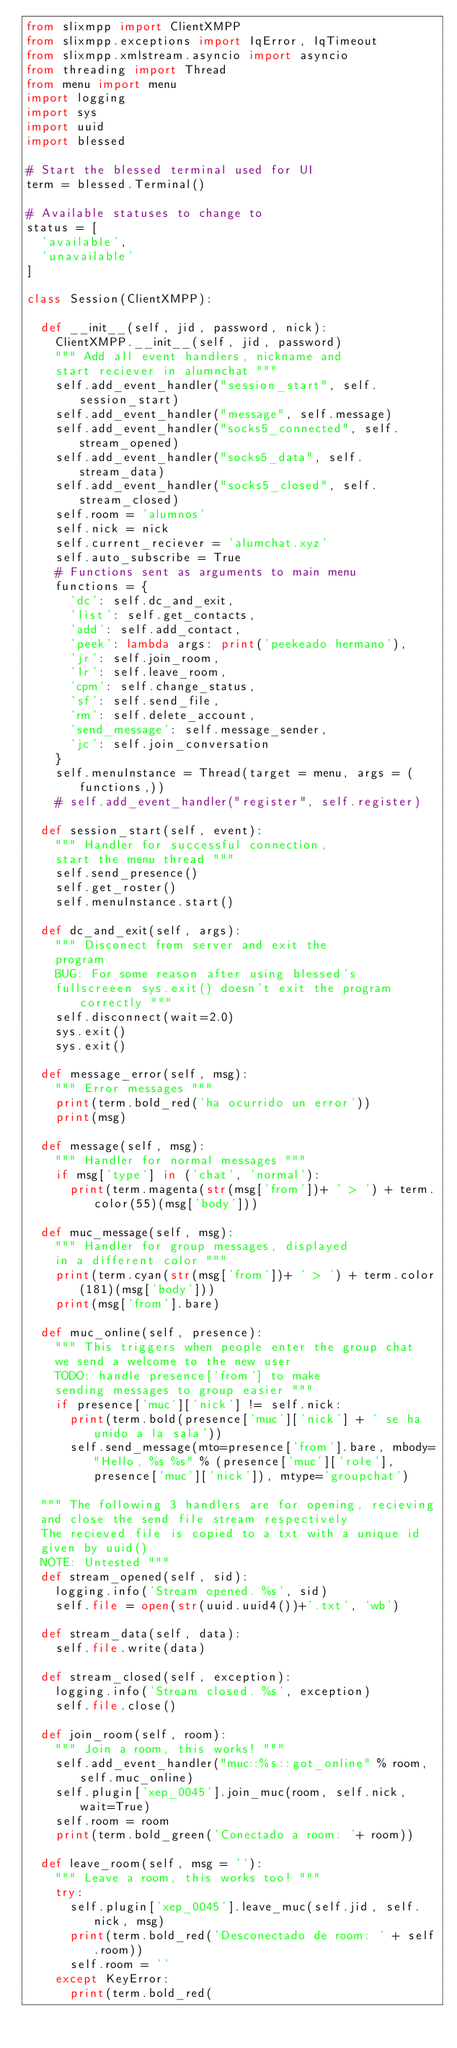<code> <loc_0><loc_0><loc_500><loc_500><_Python_>from slixmpp import ClientXMPP
from slixmpp.exceptions import IqError, IqTimeout
from slixmpp.xmlstream.asyncio import asyncio
from threading import Thread
from menu import menu
import logging
import sys
import uuid
import blessed

# Start the blessed terminal used for UI
term = blessed.Terminal()

# Available statuses to change to
status = [
  'available',
  'unavailable'
]

class Session(ClientXMPP):

  def __init__(self, jid, password, nick):
    ClientXMPP.__init__(self, jid, password)
    """ Add all event handlers, nickname and
    start reciever in alumnchat """
    self.add_event_handler("session_start", self.session_start)
    self.add_event_handler("message", self.message)
    self.add_event_handler("socks5_connected", self.stream_opened)
    self.add_event_handler("socks5_data", self.stream_data)
    self.add_event_handler("socks5_closed", self.stream_closed)
    self.room = 'alumnos'
    self.nick = nick
    self.current_reciever = 'alumchat.xyz'
    self.auto_subscribe = True
    # Functions sent as arguments to main menu
    functions = {
      'dc': self.dc_and_exit,
      'list': self.get_contacts,
      'add': self.add_contact,
      'peek': lambda args: print('peekeado hermano'),
      'jr': self.join_room,
      'lr': self.leave_room,
      'cpm': self.change_status,
      'sf': self.send_file,
      'rm': self.delete_account,
      'send_message': self.message_sender,
      'jc': self.join_conversation
    }
    self.menuInstance = Thread(target = menu, args = (functions,))
    # self.add_event_handler("register", self.register)

  def session_start(self, event):
    """ Handler for successful connection,
    start the menu thread """
    self.send_presence()
    self.get_roster()
    self.menuInstance.start()
    
  def dc_and_exit(self, args):
    """ Disconect from server and exit the 
    program
    BUG: For some reason after using blessed's
    fullscreeen sys.exit() doesn't exit the program correctly """
    self.disconnect(wait=2.0)
    sys.exit()
    sys.exit()

  def message_error(self, msg):
    """ Error messages """
    print(term.bold_red('ha ocurrido un error'))
    print(msg)
  
  def message(self, msg):
    """ Handler for normal messages """
    if msg['type'] in ('chat', 'normal'):
      print(term.magenta(str(msg['from'])+ ' > ') + term.color(55)(msg['body']))

  def muc_message(self, msg):
    """ Handler for group messages, displayed
    in a different color """
    print(term.cyan(str(msg['from'])+ ' > ') + term.color(181)(msg['body']))
    print(msg['from'].bare)
  
  def muc_online(self, presence):
    """ This triggers when people enter the group chat
    we send a welcome to the new user
    TODO: handle presence['from'] to make
    sending messages to group easier """
    if presence['muc']['nick'] != self.nick:
      print(term.bold(presence['muc']['nick'] + ' se ha unido a la sala'))
      self.send_message(mto=presence['from'].bare, mbody="Hello, %s %s" % (presence['muc']['role'], presence['muc']['nick']), mtype='groupchat')

  """ The following 3 handlers are for opening, recieving
  and close the send file stream respectively 
  The recieved file is copied to a txt with a unique id
  given by uuid()
  NOTE: Untested """
  def stream_opened(self, sid):
    logging.info('Stream opened. %s', sid)
    self.file = open(str(uuid.uuid4())+'.txt', 'wb')

  def stream_data(self, data):
    self.file.write(data)

  def stream_closed(self, exception):
    logging.info('Stream closed. %s', exception)
    self.file.close()
  
  def join_room(self, room):
    """ Join a room, this works! """
    self.add_event_handler("muc::%s::got_online" % room, self.muc_online)
    self.plugin['xep_0045'].join_muc(room, self.nick, wait=True)
    self.room = room
    print(term.bold_green('Conectado a room: '+ room))

  def leave_room(self, msg = ''):
    """ Leave a room, this works too! """
    try:
      self.plugin['xep_0045'].leave_muc(self.jid, self.nick, msg)
      print(term.bold_red('Desconectado de room: ' + self.room))
      self.room = ''
    except KeyError:
      print(term.bold_red(</code> 